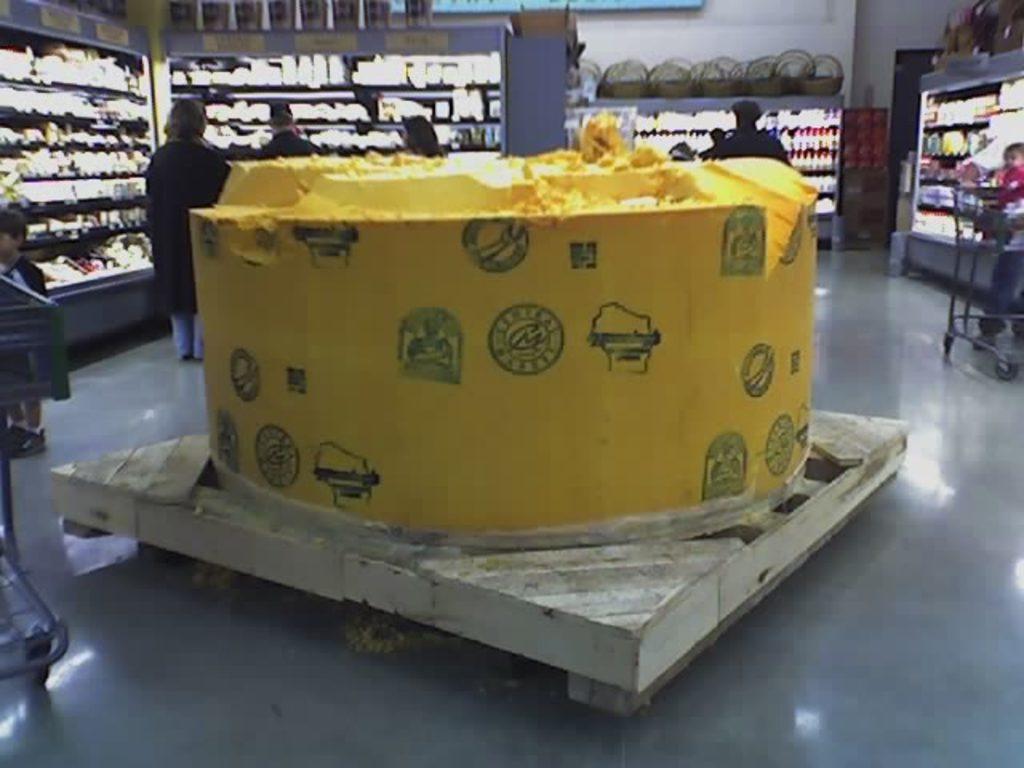Could you give a brief overview of what you see in this image? In the middle I can see the yellow color object kept on the wooden table and I can see a boy visible on the left side and I can see a baby and person and a chair visible on the right side , in the middle I can see persons and racks, in racks I can see some objects and I can see the wall. 